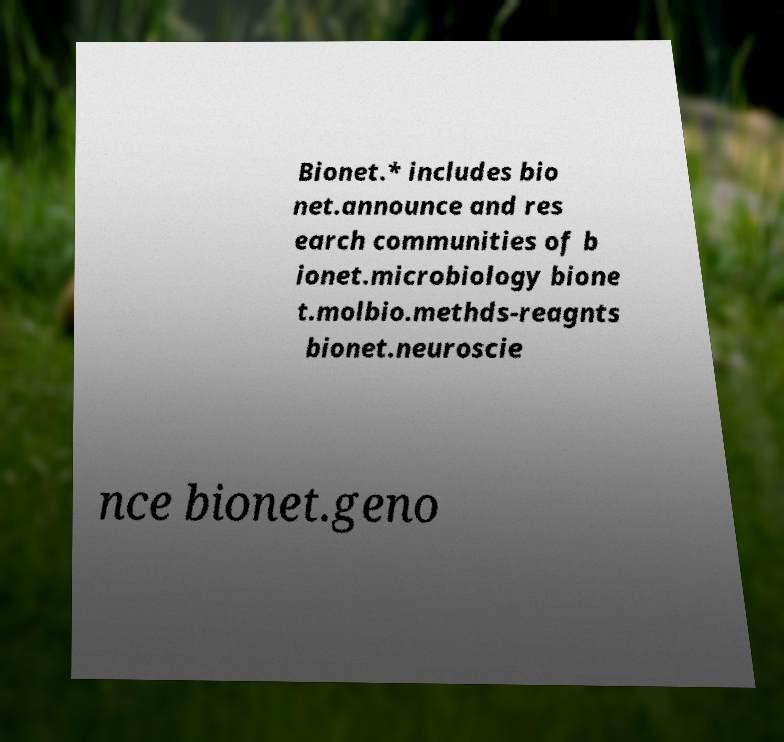I need the written content from this picture converted into text. Can you do that? Bionet.* includes bio net.announce and res earch communities of b ionet.microbiology bione t.molbio.methds-reagnts bionet.neuroscie nce bionet.geno 